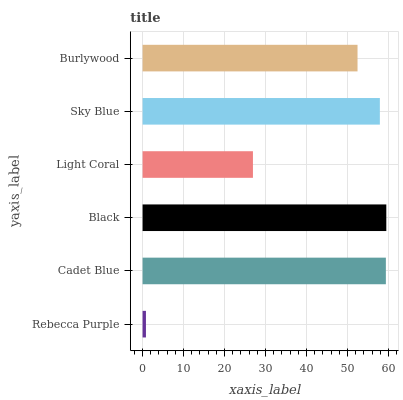Is Rebecca Purple the minimum?
Answer yes or no. Yes. Is Black the maximum?
Answer yes or no. Yes. Is Cadet Blue the minimum?
Answer yes or no. No. Is Cadet Blue the maximum?
Answer yes or no. No. Is Cadet Blue greater than Rebecca Purple?
Answer yes or no. Yes. Is Rebecca Purple less than Cadet Blue?
Answer yes or no. Yes. Is Rebecca Purple greater than Cadet Blue?
Answer yes or no. No. Is Cadet Blue less than Rebecca Purple?
Answer yes or no. No. Is Sky Blue the high median?
Answer yes or no. Yes. Is Burlywood the low median?
Answer yes or no. Yes. Is Burlywood the high median?
Answer yes or no. No. Is Cadet Blue the low median?
Answer yes or no. No. 